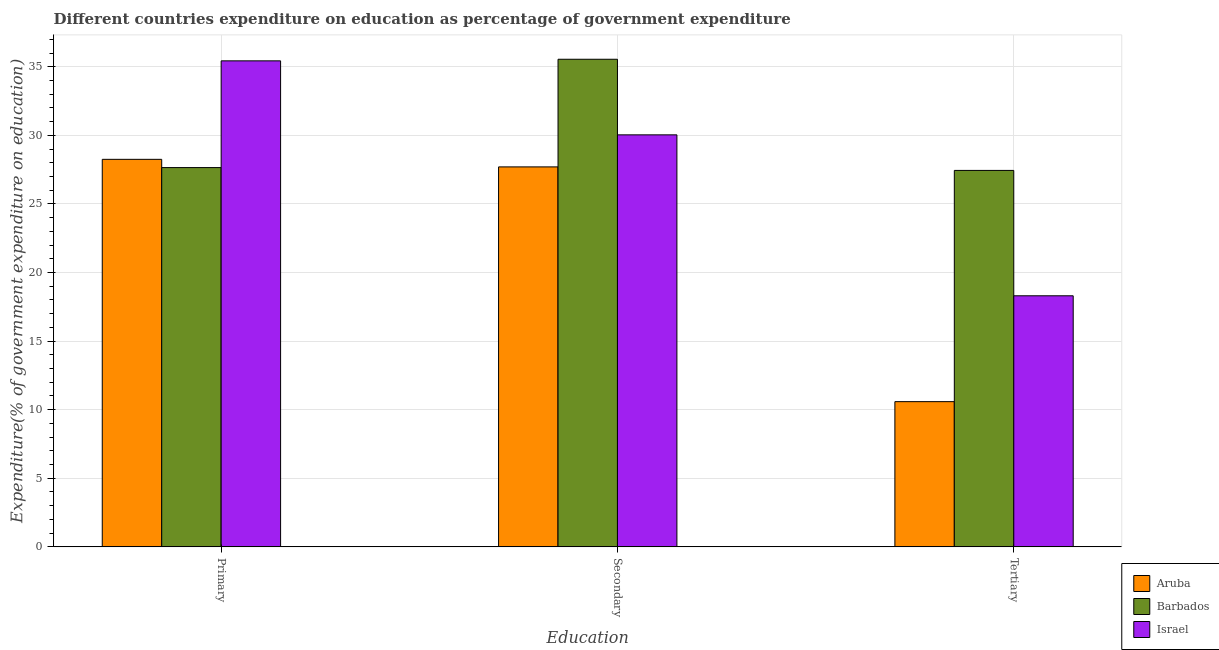Are the number of bars on each tick of the X-axis equal?
Your answer should be compact. Yes. What is the label of the 2nd group of bars from the left?
Offer a terse response. Secondary. What is the expenditure on tertiary education in Israel?
Offer a terse response. 18.3. Across all countries, what is the maximum expenditure on tertiary education?
Make the answer very short. 27.44. Across all countries, what is the minimum expenditure on tertiary education?
Offer a terse response. 10.58. In which country was the expenditure on secondary education maximum?
Your answer should be compact. Barbados. In which country was the expenditure on secondary education minimum?
Offer a terse response. Aruba. What is the total expenditure on secondary education in the graph?
Ensure brevity in your answer.  93.28. What is the difference between the expenditure on primary education in Aruba and that in Israel?
Offer a terse response. -7.18. What is the difference between the expenditure on primary education in Aruba and the expenditure on tertiary education in Barbados?
Provide a short and direct response. 0.81. What is the average expenditure on secondary education per country?
Ensure brevity in your answer.  31.09. What is the difference between the expenditure on tertiary education and expenditure on secondary education in Barbados?
Keep it short and to the point. -8.1. In how many countries, is the expenditure on secondary education greater than 11 %?
Your answer should be compact. 3. What is the ratio of the expenditure on primary education in Aruba to that in Israel?
Keep it short and to the point. 0.8. Is the expenditure on secondary education in Barbados less than that in Aruba?
Offer a terse response. No. Is the difference between the expenditure on tertiary education in Barbados and Israel greater than the difference between the expenditure on secondary education in Barbados and Israel?
Give a very brief answer. Yes. What is the difference between the highest and the second highest expenditure on primary education?
Offer a very short reply. 7.18. What is the difference between the highest and the lowest expenditure on primary education?
Offer a terse response. 7.78. What does the 1st bar from the left in Primary represents?
Provide a short and direct response. Aruba. Is it the case that in every country, the sum of the expenditure on primary education and expenditure on secondary education is greater than the expenditure on tertiary education?
Make the answer very short. Yes. How many bars are there?
Keep it short and to the point. 9. How many countries are there in the graph?
Your response must be concise. 3. What is the difference between two consecutive major ticks on the Y-axis?
Your answer should be compact. 5. Are the values on the major ticks of Y-axis written in scientific E-notation?
Your response must be concise. No. Does the graph contain any zero values?
Offer a very short reply. No. Does the graph contain grids?
Your response must be concise. Yes. Where does the legend appear in the graph?
Keep it short and to the point. Bottom right. What is the title of the graph?
Ensure brevity in your answer.  Different countries expenditure on education as percentage of government expenditure. What is the label or title of the X-axis?
Ensure brevity in your answer.  Education. What is the label or title of the Y-axis?
Ensure brevity in your answer.  Expenditure(% of government expenditure on education). What is the Expenditure(% of government expenditure on education) of Aruba in Primary?
Provide a succinct answer. 28.25. What is the Expenditure(% of government expenditure on education) of Barbados in Primary?
Your response must be concise. 27.65. What is the Expenditure(% of government expenditure on education) in Israel in Primary?
Your answer should be compact. 35.43. What is the Expenditure(% of government expenditure on education) of Aruba in Secondary?
Offer a very short reply. 27.7. What is the Expenditure(% of government expenditure on education) of Barbados in Secondary?
Your response must be concise. 35.54. What is the Expenditure(% of government expenditure on education) of Israel in Secondary?
Provide a succinct answer. 30.03. What is the Expenditure(% of government expenditure on education) of Aruba in Tertiary?
Ensure brevity in your answer.  10.58. What is the Expenditure(% of government expenditure on education) of Barbados in Tertiary?
Offer a terse response. 27.44. What is the Expenditure(% of government expenditure on education) in Israel in Tertiary?
Keep it short and to the point. 18.3. Across all Education, what is the maximum Expenditure(% of government expenditure on education) of Aruba?
Offer a terse response. 28.25. Across all Education, what is the maximum Expenditure(% of government expenditure on education) in Barbados?
Keep it short and to the point. 35.54. Across all Education, what is the maximum Expenditure(% of government expenditure on education) in Israel?
Make the answer very short. 35.43. Across all Education, what is the minimum Expenditure(% of government expenditure on education) in Aruba?
Your answer should be compact. 10.58. Across all Education, what is the minimum Expenditure(% of government expenditure on education) of Barbados?
Give a very brief answer. 27.44. Across all Education, what is the minimum Expenditure(% of government expenditure on education) of Israel?
Offer a terse response. 18.3. What is the total Expenditure(% of government expenditure on education) of Aruba in the graph?
Your response must be concise. 66.53. What is the total Expenditure(% of government expenditure on education) of Barbados in the graph?
Offer a very short reply. 90.63. What is the total Expenditure(% of government expenditure on education) of Israel in the graph?
Offer a very short reply. 83.76. What is the difference between the Expenditure(% of government expenditure on education) in Aruba in Primary and that in Secondary?
Keep it short and to the point. 0.55. What is the difference between the Expenditure(% of government expenditure on education) of Barbados in Primary and that in Secondary?
Provide a succinct answer. -7.9. What is the difference between the Expenditure(% of government expenditure on education) of Israel in Primary and that in Secondary?
Make the answer very short. 5.39. What is the difference between the Expenditure(% of government expenditure on education) in Aruba in Primary and that in Tertiary?
Provide a short and direct response. 17.66. What is the difference between the Expenditure(% of government expenditure on education) in Barbados in Primary and that in Tertiary?
Your response must be concise. 0.21. What is the difference between the Expenditure(% of government expenditure on education) in Israel in Primary and that in Tertiary?
Keep it short and to the point. 17.13. What is the difference between the Expenditure(% of government expenditure on education) in Aruba in Secondary and that in Tertiary?
Provide a succinct answer. 17.11. What is the difference between the Expenditure(% of government expenditure on education) in Barbados in Secondary and that in Tertiary?
Keep it short and to the point. 8.1. What is the difference between the Expenditure(% of government expenditure on education) of Israel in Secondary and that in Tertiary?
Keep it short and to the point. 11.73. What is the difference between the Expenditure(% of government expenditure on education) of Aruba in Primary and the Expenditure(% of government expenditure on education) of Barbados in Secondary?
Keep it short and to the point. -7.3. What is the difference between the Expenditure(% of government expenditure on education) in Aruba in Primary and the Expenditure(% of government expenditure on education) in Israel in Secondary?
Your response must be concise. -1.78. What is the difference between the Expenditure(% of government expenditure on education) in Barbados in Primary and the Expenditure(% of government expenditure on education) in Israel in Secondary?
Keep it short and to the point. -2.39. What is the difference between the Expenditure(% of government expenditure on education) in Aruba in Primary and the Expenditure(% of government expenditure on education) in Barbados in Tertiary?
Ensure brevity in your answer.  0.81. What is the difference between the Expenditure(% of government expenditure on education) in Aruba in Primary and the Expenditure(% of government expenditure on education) in Israel in Tertiary?
Provide a short and direct response. 9.95. What is the difference between the Expenditure(% of government expenditure on education) in Barbados in Primary and the Expenditure(% of government expenditure on education) in Israel in Tertiary?
Your response must be concise. 9.35. What is the difference between the Expenditure(% of government expenditure on education) in Aruba in Secondary and the Expenditure(% of government expenditure on education) in Barbados in Tertiary?
Provide a succinct answer. 0.26. What is the difference between the Expenditure(% of government expenditure on education) in Aruba in Secondary and the Expenditure(% of government expenditure on education) in Israel in Tertiary?
Offer a very short reply. 9.4. What is the difference between the Expenditure(% of government expenditure on education) of Barbados in Secondary and the Expenditure(% of government expenditure on education) of Israel in Tertiary?
Provide a short and direct response. 17.24. What is the average Expenditure(% of government expenditure on education) in Aruba per Education?
Your answer should be very brief. 22.18. What is the average Expenditure(% of government expenditure on education) in Barbados per Education?
Give a very brief answer. 30.21. What is the average Expenditure(% of government expenditure on education) in Israel per Education?
Your answer should be compact. 27.92. What is the difference between the Expenditure(% of government expenditure on education) in Aruba and Expenditure(% of government expenditure on education) in Barbados in Primary?
Your answer should be compact. 0.6. What is the difference between the Expenditure(% of government expenditure on education) in Aruba and Expenditure(% of government expenditure on education) in Israel in Primary?
Your response must be concise. -7.18. What is the difference between the Expenditure(% of government expenditure on education) of Barbados and Expenditure(% of government expenditure on education) of Israel in Primary?
Give a very brief answer. -7.78. What is the difference between the Expenditure(% of government expenditure on education) of Aruba and Expenditure(% of government expenditure on education) of Barbados in Secondary?
Your answer should be compact. -7.85. What is the difference between the Expenditure(% of government expenditure on education) of Aruba and Expenditure(% of government expenditure on education) of Israel in Secondary?
Your response must be concise. -2.34. What is the difference between the Expenditure(% of government expenditure on education) of Barbados and Expenditure(% of government expenditure on education) of Israel in Secondary?
Make the answer very short. 5.51. What is the difference between the Expenditure(% of government expenditure on education) in Aruba and Expenditure(% of government expenditure on education) in Barbados in Tertiary?
Make the answer very short. -16.86. What is the difference between the Expenditure(% of government expenditure on education) of Aruba and Expenditure(% of government expenditure on education) of Israel in Tertiary?
Keep it short and to the point. -7.72. What is the difference between the Expenditure(% of government expenditure on education) of Barbados and Expenditure(% of government expenditure on education) of Israel in Tertiary?
Offer a terse response. 9.14. What is the ratio of the Expenditure(% of government expenditure on education) of Aruba in Primary to that in Secondary?
Give a very brief answer. 1.02. What is the ratio of the Expenditure(% of government expenditure on education) in Israel in Primary to that in Secondary?
Keep it short and to the point. 1.18. What is the ratio of the Expenditure(% of government expenditure on education) of Aruba in Primary to that in Tertiary?
Offer a terse response. 2.67. What is the ratio of the Expenditure(% of government expenditure on education) in Barbados in Primary to that in Tertiary?
Make the answer very short. 1.01. What is the ratio of the Expenditure(% of government expenditure on education) of Israel in Primary to that in Tertiary?
Provide a succinct answer. 1.94. What is the ratio of the Expenditure(% of government expenditure on education) in Aruba in Secondary to that in Tertiary?
Your response must be concise. 2.62. What is the ratio of the Expenditure(% of government expenditure on education) of Barbados in Secondary to that in Tertiary?
Provide a succinct answer. 1.3. What is the ratio of the Expenditure(% of government expenditure on education) of Israel in Secondary to that in Tertiary?
Offer a terse response. 1.64. What is the difference between the highest and the second highest Expenditure(% of government expenditure on education) of Aruba?
Offer a terse response. 0.55. What is the difference between the highest and the second highest Expenditure(% of government expenditure on education) in Barbados?
Offer a terse response. 7.9. What is the difference between the highest and the second highest Expenditure(% of government expenditure on education) in Israel?
Your response must be concise. 5.39. What is the difference between the highest and the lowest Expenditure(% of government expenditure on education) of Aruba?
Give a very brief answer. 17.66. What is the difference between the highest and the lowest Expenditure(% of government expenditure on education) in Barbados?
Your response must be concise. 8.1. What is the difference between the highest and the lowest Expenditure(% of government expenditure on education) of Israel?
Give a very brief answer. 17.13. 